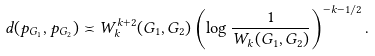Convert formula to latex. <formula><loc_0><loc_0><loc_500><loc_500>d ( p _ { G _ { 1 } } , p _ { G _ { 2 } } ) \asymp W _ { k } ^ { k + 2 } ( G _ { 1 } , G _ { 2 } ) \left ( \log \frac { 1 } { W _ { k } ( G _ { 1 } , G _ { 2 } ) } \right ) ^ { - k - 1 / 2 } .</formula> 